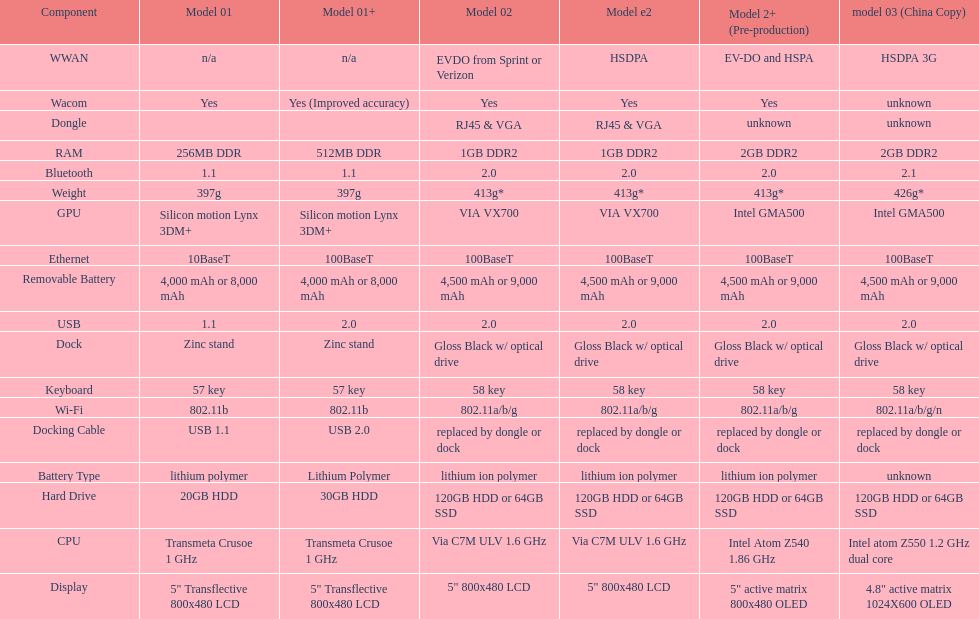The model 2 and the model 2e have what type of cpu? Via C7M ULV 1.6 GHz. 